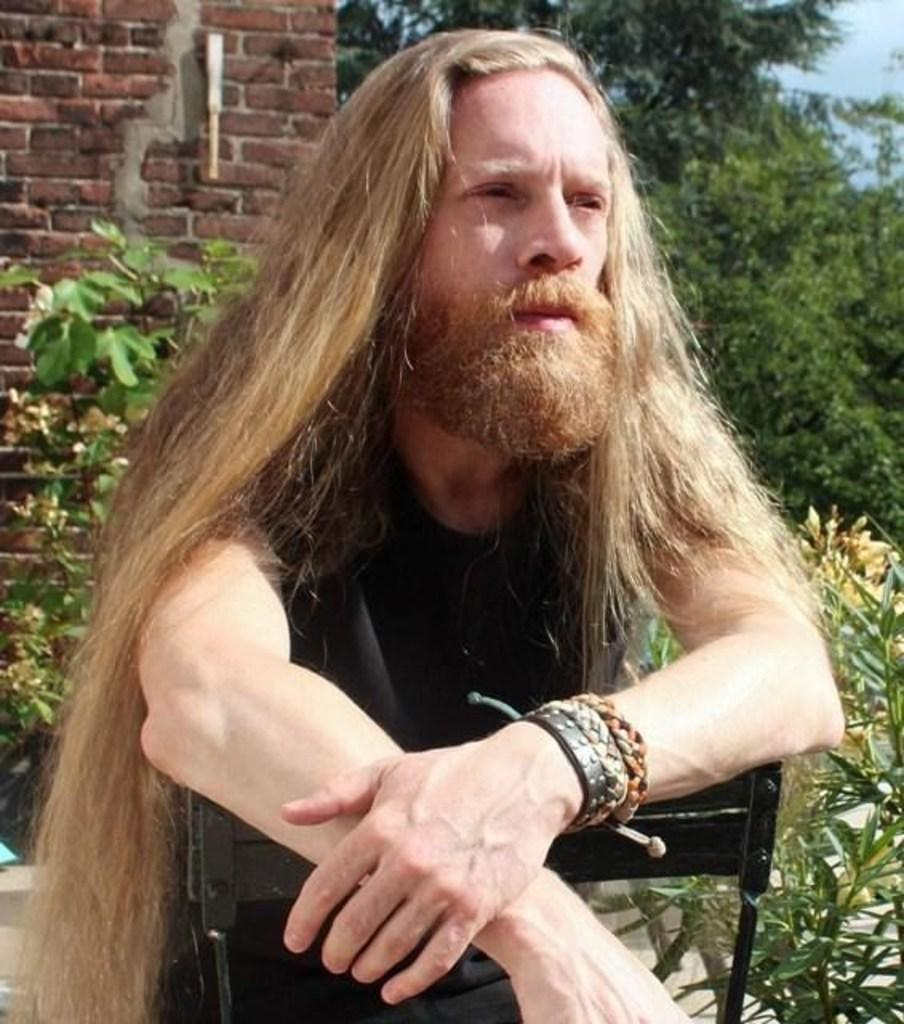What is the person in the image doing? There is a person sitting on a chair in the image. What is located behind the person in the image? There is a wall visible in the image. What type of vegetation can be seen in the image? There are plants in the image. What part of the natural environment is visible in the image? The sky is visible in the image. What type of discovery was made during the meeting in the image? There is no indication of a meeting or any discovery being made in the image. 